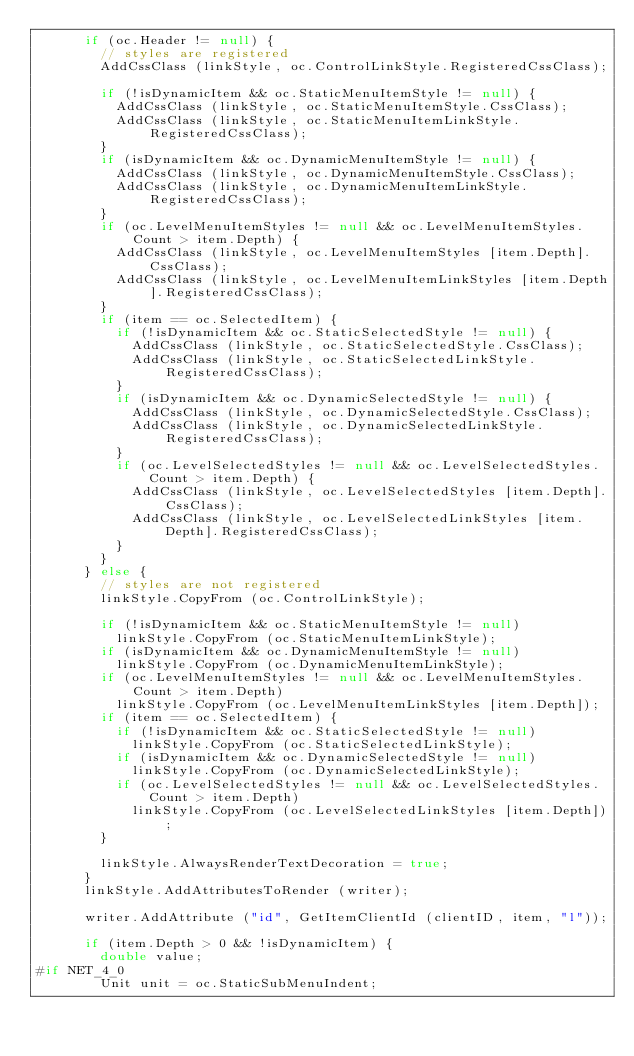<code> <loc_0><loc_0><loc_500><loc_500><_C#_>			if (oc.Header != null) {
				// styles are registered
				AddCssClass (linkStyle, oc.ControlLinkStyle.RegisteredCssClass);

				if (!isDynamicItem && oc.StaticMenuItemStyle != null) {
					AddCssClass (linkStyle, oc.StaticMenuItemStyle.CssClass);
					AddCssClass (linkStyle, oc.StaticMenuItemLinkStyle.RegisteredCssClass);
				}
				if (isDynamicItem && oc.DynamicMenuItemStyle != null) {
					AddCssClass (linkStyle, oc.DynamicMenuItemStyle.CssClass);
					AddCssClass (linkStyle, oc.DynamicMenuItemLinkStyle.RegisteredCssClass);
				}
				if (oc.LevelMenuItemStyles != null && oc.LevelMenuItemStyles.Count > item.Depth) {
					AddCssClass (linkStyle, oc.LevelMenuItemStyles [item.Depth].CssClass);
					AddCssClass (linkStyle, oc.LevelMenuItemLinkStyles [item.Depth].RegisteredCssClass);
				}
				if (item == oc.SelectedItem) {
					if (!isDynamicItem && oc.StaticSelectedStyle != null) {
						AddCssClass (linkStyle, oc.StaticSelectedStyle.CssClass);
						AddCssClass (linkStyle, oc.StaticSelectedLinkStyle.RegisteredCssClass);
					}
					if (isDynamicItem && oc.DynamicSelectedStyle != null) {
						AddCssClass (linkStyle, oc.DynamicSelectedStyle.CssClass);
						AddCssClass (linkStyle, oc.DynamicSelectedLinkStyle.RegisteredCssClass);
					}
					if (oc.LevelSelectedStyles != null && oc.LevelSelectedStyles.Count > item.Depth) {
						AddCssClass (linkStyle, oc.LevelSelectedStyles [item.Depth].CssClass);
						AddCssClass (linkStyle, oc.LevelSelectedLinkStyles [item.Depth].RegisteredCssClass);
					}
				}
			} else {
				// styles are not registered
				linkStyle.CopyFrom (oc.ControlLinkStyle);

				if (!isDynamicItem && oc.StaticMenuItemStyle != null)
					linkStyle.CopyFrom (oc.StaticMenuItemLinkStyle);
				if (isDynamicItem && oc.DynamicMenuItemStyle != null)
					linkStyle.CopyFrom (oc.DynamicMenuItemLinkStyle);
				if (oc.LevelMenuItemStyles != null && oc.LevelMenuItemStyles.Count > item.Depth)
					linkStyle.CopyFrom (oc.LevelMenuItemLinkStyles [item.Depth]);
				if (item == oc.SelectedItem) {
					if (!isDynamicItem && oc.StaticSelectedStyle != null)
						linkStyle.CopyFrom (oc.StaticSelectedLinkStyle);
					if (isDynamicItem && oc.DynamicSelectedStyle != null)
						linkStyle.CopyFrom (oc.DynamicSelectedLinkStyle);
					if (oc.LevelSelectedStyles != null && oc.LevelSelectedStyles.Count > item.Depth)
						linkStyle.CopyFrom (oc.LevelSelectedLinkStyles [item.Depth]);
				}

				linkStyle.AlwaysRenderTextDecoration = true;
			}
			linkStyle.AddAttributesToRender (writer);

			writer.AddAttribute ("id", GetItemClientId (clientID, item, "l"));
			
			if (item.Depth > 0 && !isDynamicItem) {
				double value;
#if NET_4_0
				Unit unit = oc.StaticSubMenuIndent;</code> 